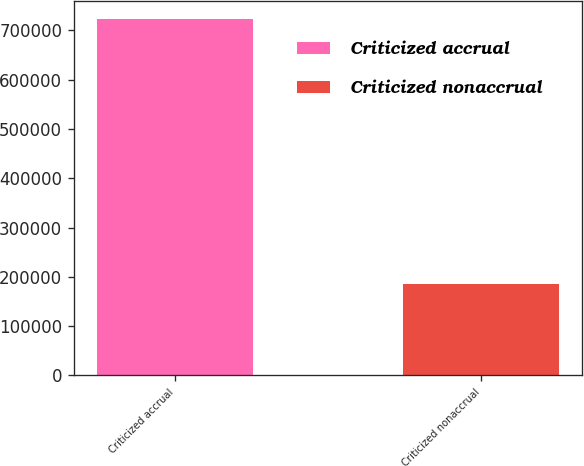<chart> <loc_0><loc_0><loc_500><loc_500><bar_chart><fcel>Criticized accrual<fcel>Criticized nonaccrual<nl><fcel>723777<fcel>184982<nl></chart> 